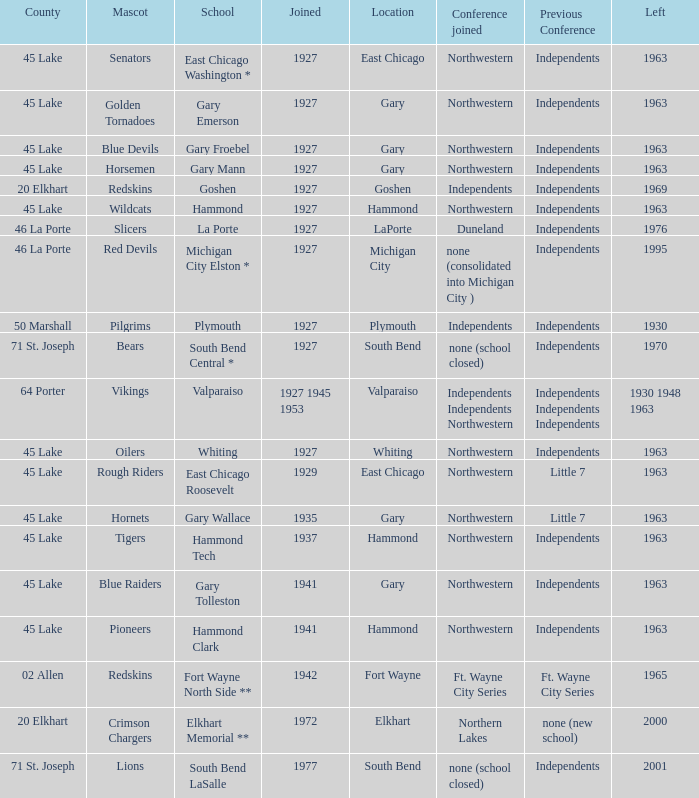When doeas Mascot of blue devils in Gary Froebel School? 1927.0. 